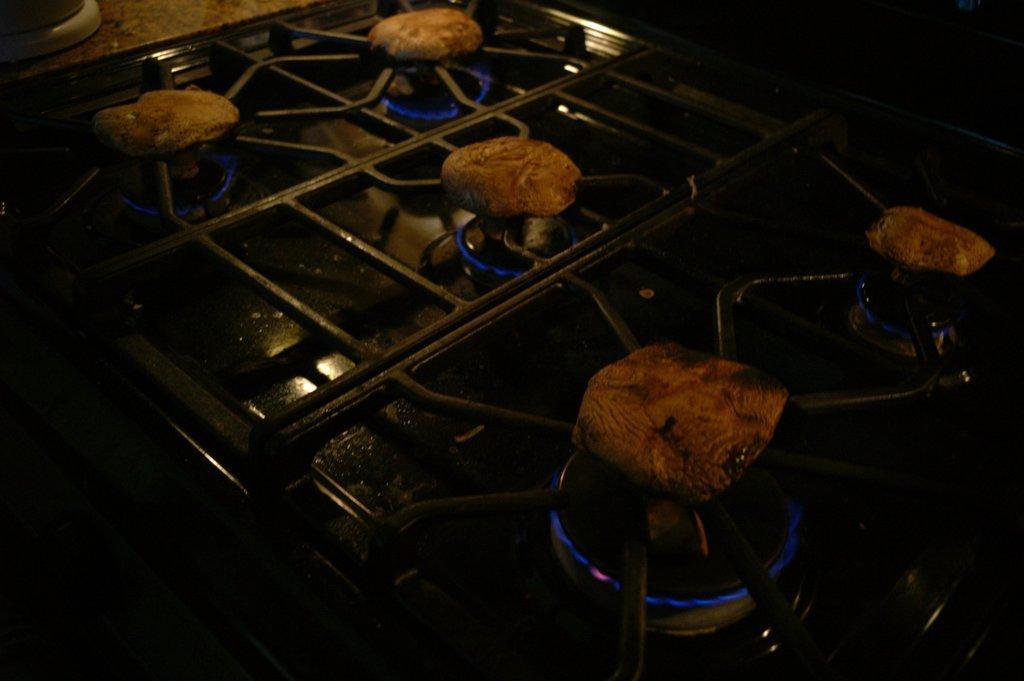Can you describe this image briefly? There is a stove with flames. On the stove there are grills with food items on the flames. 